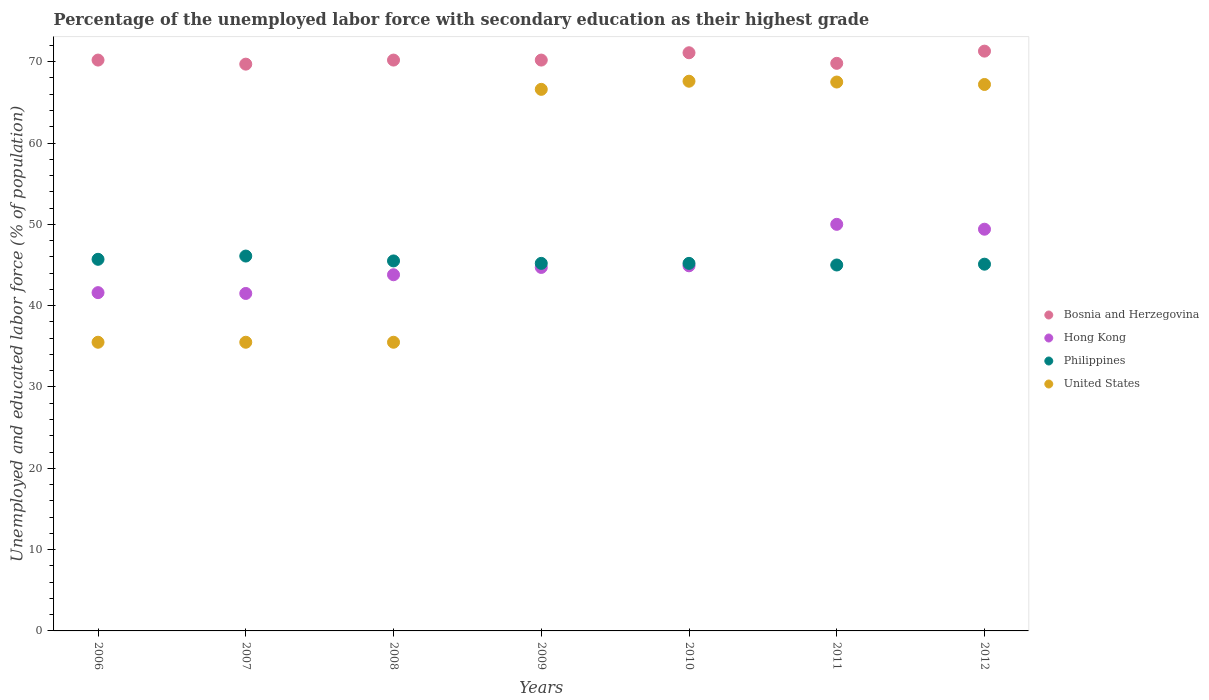What is the percentage of the unemployed labor force with secondary education in Philippines in 2010?
Keep it short and to the point. 45.2. Across all years, what is the maximum percentage of the unemployed labor force with secondary education in Philippines?
Keep it short and to the point. 46.1. Across all years, what is the minimum percentage of the unemployed labor force with secondary education in United States?
Give a very brief answer. 35.5. In which year was the percentage of the unemployed labor force with secondary education in United States maximum?
Provide a succinct answer. 2010. What is the total percentage of the unemployed labor force with secondary education in Philippines in the graph?
Provide a succinct answer. 317.8. What is the difference between the percentage of the unemployed labor force with secondary education in Philippines in 2006 and that in 2012?
Your response must be concise. 0.6. What is the average percentage of the unemployed labor force with secondary education in Hong Kong per year?
Keep it short and to the point. 45.13. In how many years, is the percentage of the unemployed labor force with secondary education in Hong Kong greater than 46 %?
Make the answer very short. 2. What is the ratio of the percentage of the unemployed labor force with secondary education in Hong Kong in 2007 to that in 2012?
Give a very brief answer. 0.84. What is the difference between the highest and the second highest percentage of the unemployed labor force with secondary education in Philippines?
Give a very brief answer. 0.4. What is the difference between the highest and the lowest percentage of the unemployed labor force with secondary education in Philippines?
Give a very brief answer. 1.1. In how many years, is the percentage of the unemployed labor force with secondary education in Bosnia and Herzegovina greater than the average percentage of the unemployed labor force with secondary education in Bosnia and Herzegovina taken over all years?
Offer a very short reply. 2. Is the sum of the percentage of the unemployed labor force with secondary education in United States in 2007 and 2012 greater than the maximum percentage of the unemployed labor force with secondary education in Hong Kong across all years?
Keep it short and to the point. Yes. Does the percentage of the unemployed labor force with secondary education in Bosnia and Herzegovina monotonically increase over the years?
Your answer should be very brief. No. Is the percentage of the unemployed labor force with secondary education in Bosnia and Herzegovina strictly less than the percentage of the unemployed labor force with secondary education in Philippines over the years?
Your answer should be very brief. No. How many dotlines are there?
Ensure brevity in your answer.  4. How many years are there in the graph?
Keep it short and to the point. 7. What is the difference between two consecutive major ticks on the Y-axis?
Offer a terse response. 10. Are the values on the major ticks of Y-axis written in scientific E-notation?
Provide a short and direct response. No. Does the graph contain any zero values?
Your answer should be compact. No. Does the graph contain grids?
Provide a short and direct response. No. Where does the legend appear in the graph?
Keep it short and to the point. Center right. What is the title of the graph?
Your answer should be compact. Percentage of the unemployed labor force with secondary education as their highest grade. What is the label or title of the Y-axis?
Your answer should be very brief. Unemployed and educated labor force (% of population). What is the Unemployed and educated labor force (% of population) of Bosnia and Herzegovina in 2006?
Give a very brief answer. 70.2. What is the Unemployed and educated labor force (% of population) in Hong Kong in 2006?
Give a very brief answer. 41.6. What is the Unemployed and educated labor force (% of population) in Philippines in 2006?
Offer a terse response. 45.7. What is the Unemployed and educated labor force (% of population) in United States in 2006?
Keep it short and to the point. 35.5. What is the Unemployed and educated labor force (% of population) of Bosnia and Herzegovina in 2007?
Ensure brevity in your answer.  69.7. What is the Unemployed and educated labor force (% of population) in Hong Kong in 2007?
Give a very brief answer. 41.5. What is the Unemployed and educated labor force (% of population) of Philippines in 2007?
Your response must be concise. 46.1. What is the Unemployed and educated labor force (% of population) of United States in 2007?
Offer a very short reply. 35.5. What is the Unemployed and educated labor force (% of population) of Bosnia and Herzegovina in 2008?
Keep it short and to the point. 70.2. What is the Unemployed and educated labor force (% of population) of Hong Kong in 2008?
Keep it short and to the point. 43.8. What is the Unemployed and educated labor force (% of population) of Philippines in 2008?
Your answer should be very brief. 45.5. What is the Unemployed and educated labor force (% of population) of United States in 2008?
Make the answer very short. 35.5. What is the Unemployed and educated labor force (% of population) of Bosnia and Herzegovina in 2009?
Offer a very short reply. 70.2. What is the Unemployed and educated labor force (% of population) of Hong Kong in 2009?
Provide a succinct answer. 44.7. What is the Unemployed and educated labor force (% of population) in Philippines in 2009?
Offer a very short reply. 45.2. What is the Unemployed and educated labor force (% of population) in United States in 2009?
Your answer should be very brief. 66.6. What is the Unemployed and educated labor force (% of population) in Bosnia and Herzegovina in 2010?
Offer a very short reply. 71.1. What is the Unemployed and educated labor force (% of population) in Hong Kong in 2010?
Offer a very short reply. 44.9. What is the Unemployed and educated labor force (% of population) in Philippines in 2010?
Your response must be concise. 45.2. What is the Unemployed and educated labor force (% of population) of United States in 2010?
Give a very brief answer. 67.6. What is the Unemployed and educated labor force (% of population) in Bosnia and Herzegovina in 2011?
Keep it short and to the point. 69.8. What is the Unemployed and educated labor force (% of population) of United States in 2011?
Provide a short and direct response. 67.5. What is the Unemployed and educated labor force (% of population) of Bosnia and Herzegovina in 2012?
Offer a terse response. 71.3. What is the Unemployed and educated labor force (% of population) in Hong Kong in 2012?
Ensure brevity in your answer.  49.4. What is the Unemployed and educated labor force (% of population) in Philippines in 2012?
Offer a terse response. 45.1. What is the Unemployed and educated labor force (% of population) of United States in 2012?
Your answer should be very brief. 67.2. Across all years, what is the maximum Unemployed and educated labor force (% of population) in Bosnia and Herzegovina?
Offer a very short reply. 71.3. Across all years, what is the maximum Unemployed and educated labor force (% of population) in Philippines?
Your answer should be compact. 46.1. Across all years, what is the maximum Unemployed and educated labor force (% of population) in United States?
Your answer should be very brief. 67.6. Across all years, what is the minimum Unemployed and educated labor force (% of population) in Bosnia and Herzegovina?
Ensure brevity in your answer.  69.7. Across all years, what is the minimum Unemployed and educated labor force (% of population) in Hong Kong?
Your answer should be very brief. 41.5. Across all years, what is the minimum Unemployed and educated labor force (% of population) of Philippines?
Your answer should be compact. 45. Across all years, what is the minimum Unemployed and educated labor force (% of population) in United States?
Make the answer very short. 35.5. What is the total Unemployed and educated labor force (% of population) of Bosnia and Herzegovina in the graph?
Provide a short and direct response. 492.5. What is the total Unemployed and educated labor force (% of population) in Hong Kong in the graph?
Ensure brevity in your answer.  315.9. What is the total Unemployed and educated labor force (% of population) in Philippines in the graph?
Ensure brevity in your answer.  317.8. What is the total Unemployed and educated labor force (% of population) of United States in the graph?
Offer a very short reply. 375.4. What is the difference between the Unemployed and educated labor force (% of population) of Philippines in 2006 and that in 2007?
Ensure brevity in your answer.  -0.4. What is the difference between the Unemployed and educated labor force (% of population) of Bosnia and Herzegovina in 2006 and that in 2008?
Give a very brief answer. 0. What is the difference between the Unemployed and educated labor force (% of population) of United States in 2006 and that in 2009?
Give a very brief answer. -31.1. What is the difference between the Unemployed and educated labor force (% of population) of Bosnia and Herzegovina in 2006 and that in 2010?
Make the answer very short. -0.9. What is the difference between the Unemployed and educated labor force (% of population) in Philippines in 2006 and that in 2010?
Your answer should be very brief. 0.5. What is the difference between the Unemployed and educated labor force (% of population) of United States in 2006 and that in 2010?
Provide a short and direct response. -32.1. What is the difference between the Unemployed and educated labor force (% of population) in Philippines in 2006 and that in 2011?
Offer a very short reply. 0.7. What is the difference between the Unemployed and educated labor force (% of population) in United States in 2006 and that in 2011?
Provide a short and direct response. -32. What is the difference between the Unemployed and educated labor force (% of population) in Hong Kong in 2006 and that in 2012?
Make the answer very short. -7.8. What is the difference between the Unemployed and educated labor force (% of population) in Philippines in 2006 and that in 2012?
Provide a succinct answer. 0.6. What is the difference between the Unemployed and educated labor force (% of population) in United States in 2006 and that in 2012?
Keep it short and to the point. -31.7. What is the difference between the Unemployed and educated labor force (% of population) of Philippines in 2007 and that in 2008?
Offer a very short reply. 0.6. What is the difference between the Unemployed and educated labor force (% of population) of United States in 2007 and that in 2008?
Provide a succinct answer. 0. What is the difference between the Unemployed and educated labor force (% of population) in Bosnia and Herzegovina in 2007 and that in 2009?
Provide a succinct answer. -0.5. What is the difference between the Unemployed and educated labor force (% of population) of Philippines in 2007 and that in 2009?
Your answer should be very brief. 0.9. What is the difference between the Unemployed and educated labor force (% of population) in United States in 2007 and that in 2009?
Ensure brevity in your answer.  -31.1. What is the difference between the Unemployed and educated labor force (% of population) of Bosnia and Herzegovina in 2007 and that in 2010?
Ensure brevity in your answer.  -1.4. What is the difference between the Unemployed and educated labor force (% of population) of United States in 2007 and that in 2010?
Offer a very short reply. -32.1. What is the difference between the Unemployed and educated labor force (% of population) in Bosnia and Herzegovina in 2007 and that in 2011?
Give a very brief answer. -0.1. What is the difference between the Unemployed and educated labor force (% of population) in Hong Kong in 2007 and that in 2011?
Provide a succinct answer. -8.5. What is the difference between the Unemployed and educated labor force (% of population) in United States in 2007 and that in 2011?
Ensure brevity in your answer.  -32. What is the difference between the Unemployed and educated labor force (% of population) of Hong Kong in 2007 and that in 2012?
Ensure brevity in your answer.  -7.9. What is the difference between the Unemployed and educated labor force (% of population) of United States in 2007 and that in 2012?
Make the answer very short. -31.7. What is the difference between the Unemployed and educated labor force (% of population) in United States in 2008 and that in 2009?
Give a very brief answer. -31.1. What is the difference between the Unemployed and educated labor force (% of population) in Bosnia and Herzegovina in 2008 and that in 2010?
Give a very brief answer. -0.9. What is the difference between the Unemployed and educated labor force (% of population) in Hong Kong in 2008 and that in 2010?
Offer a terse response. -1.1. What is the difference between the Unemployed and educated labor force (% of population) of United States in 2008 and that in 2010?
Keep it short and to the point. -32.1. What is the difference between the Unemployed and educated labor force (% of population) in Bosnia and Herzegovina in 2008 and that in 2011?
Offer a terse response. 0.4. What is the difference between the Unemployed and educated labor force (% of population) of Philippines in 2008 and that in 2011?
Offer a very short reply. 0.5. What is the difference between the Unemployed and educated labor force (% of population) in United States in 2008 and that in 2011?
Offer a terse response. -32. What is the difference between the Unemployed and educated labor force (% of population) of Philippines in 2008 and that in 2012?
Offer a very short reply. 0.4. What is the difference between the Unemployed and educated labor force (% of population) in United States in 2008 and that in 2012?
Make the answer very short. -31.7. What is the difference between the Unemployed and educated labor force (% of population) in Hong Kong in 2009 and that in 2010?
Your answer should be compact. -0.2. What is the difference between the Unemployed and educated labor force (% of population) in United States in 2009 and that in 2010?
Provide a short and direct response. -1. What is the difference between the Unemployed and educated labor force (% of population) of Hong Kong in 2009 and that in 2011?
Your answer should be very brief. -5.3. What is the difference between the Unemployed and educated labor force (% of population) of United States in 2009 and that in 2011?
Your answer should be compact. -0.9. What is the difference between the Unemployed and educated labor force (% of population) in Hong Kong in 2009 and that in 2012?
Provide a succinct answer. -4.7. What is the difference between the Unemployed and educated labor force (% of population) in United States in 2009 and that in 2012?
Give a very brief answer. -0.6. What is the difference between the Unemployed and educated labor force (% of population) of Bosnia and Herzegovina in 2010 and that in 2011?
Keep it short and to the point. 1.3. What is the difference between the Unemployed and educated labor force (% of population) of Philippines in 2010 and that in 2011?
Provide a succinct answer. 0.2. What is the difference between the Unemployed and educated labor force (% of population) in Bosnia and Herzegovina in 2010 and that in 2012?
Make the answer very short. -0.2. What is the difference between the Unemployed and educated labor force (% of population) in Hong Kong in 2010 and that in 2012?
Your response must be concise. -4.5. What is the difference between the Unemployed and educated labor force (% of population) of Bosnia and Herzegovina in 2011 and that in 2012?
Provide a short and direct response. -1.5. What is the difference between the Unemployed and educated labor force (% of population) of Hong Kong in 2011 and that in 2012?
Make the answer very short. 0.6. What is the difference between the Unemployed and educated labor force (% of population) of Philippines in 2011 and that in 2012?
Provide a short and direct response. -0.1. What is the difference between the Unemployed and educated labor force (% of population) of Bosnia and Herzegovina in 2006 and the Unemployed and educated labor force (% of population) of Hong Kong in 2007?
Your answer should be very brief. 28.7. What is the difference between the Unemployed and educated labor force (% of population) of Bosnia and Herzegovina in 2006 and the Unemployed and educated labor force (% of population) of Philippines in 2007?
Give a very brief answer. 24.1. What is the difference between the Unemployed and educated labor force (% of population) of Bosnia and Herzegovina in 2006 and the Unemployed and educated labor force (% of population) of United States in 2007?
Provide a succinct answer. 34.7. What is the difference between the Unemployed and educated labor force (% of population) of Hong Kong in 2006 and the Unemployed and educated labor force (% of population) of United States in 2007?
Keep it short and to the point. 6.1. What is the difference between the Unemployed and educated labor force (% of population) in Philippines in 2006 and the Unemployed and educated labor force (% of population) in United States in 2007?
Provide a short and direct response. 10.2. What is the difference between the Unemployed and educated labor force (% of population) of Bosnia and Herzegovina in 2006 and the Unemployed and educated labor force (% of population) of Hong Kong in 2008?
Ensure brevity in your answer.  26.4. What is the difference between the Unemployed and educated labor force (% of population) of Bosnia and Herzegovina in 2006 and the Unemployed and educated labor force (% of population) of Philippines in 2008?
Provide a short and direct response. 24.7. What is the difference between the Unemployed and educated labor force (% of population) in Bosnia and Herzegovina in 2006 and the Unemployed and educated labor force (% of population) in United States in 2008?
Provide a short and direct response. 34.7. What is the difference between the Unemployed and educated labor force (% of population) of Philippines in 2006 and the Unemployed and educated labor force (% of population) of United States in 2008?
Provide a succinct answer. 10.2. What is the difference between the Unemployed and educated labor force (% of population) in Bosnia and Herzegovina in 2006 and the Unemployed and educated labor force (% of population) in Hong Kong in 2009?
Your answer should be compact. 25.5. What is the difference between the Unemployed and educated labor force (% of population) in Hong Kong in 2006 and the Unemployed and educated labor force (% of population) in Philippines in 2009?
Provide a short and direct response. -3.6. What is the difference between the Unemployed and educated labor force (% of population) of Philippines in 2006 and the Unemployed and educated labor force (% of population) of United States in 2009?
Offer a very short reply. -20.9. What is the difference between the Unemployed and educated labor force (% of population) of Bosnia and Herzegovina in 2006 and the Unemployed and educated labor force (% of population) of Hong Kong in 2010?
Your answer should be compact. 25.3. What is the difference between the Unemployed and educated labor force (% of population) of Bosnia and Herzegovina in 2006 and the Unemployed and educated labor force (% of population) of United States in 2010?
Keep it short and to the point. 2.6. What is the difference between the Unemployed and educated labor force (% of population) of Hong Kong in 2006 and the Unemployed and educated labor force (% of population) of United States in 2010?
Your answer should be compact. -26. What is the difference between the Unemployed and educated labor force (% of population) in Philippines in 2006 and the Unemployed and educated labor force (% of population) in United States in 2010?
Your response must be concise. -21.9. What is the difference between the Unemployed and educated labor force (% of population) of Bosnia and Herzegovina in 2006 and the Unemployed and educated labor force (% of population) of Hong Kong in 2011?
Your answer should be compact. 20.2. What is the difference between the Unemployed and educated labor force (% of population) in Bosnia and Herzegovina in 2006 and the Unemployed and educated labor force (% of population) in Philippines in 2011?
Offer a very short reply. 25.2. What is the difference between the Unemployed and educated labor force (% of population) in Hong Kong in 2006 and the Unemployed and educated labor force (% of population) in Philippines in 2011?
Offer a terse response. -3.4. What is the difference between the Unemployed and educated labor force (% of population) in Hong Kong in 2006 and the Unemployed and educated labor force (% of population) in United States in 2011?
Give a very brief answer. -25.9. What is the difference between the Unemployed and educated labor force (% of population) in Philippines in 2006 and the Unemployed and educated labor force (% of population) in United States in 2011?
Give a very brief answer. -21.8. What is the difference between the Unemployed and educated labor force (% of population) in Bosnia and Herzegovina in 2006 and the Unemployed and educated labor force (% of population) in Hong Kong in 2012?
Give a very brief answer. 20.8. What is the difference between the Unemployed and educated labor force (% of population) of Bosnia and Herzegovina in 2006 and the Unemployed and educated labor force (% of population) of Philippines in 2012?
Your response must be concise. 25.1. What is the difference between the Unemployed and educated labor force (% of population) in Hong Kong in 2006 and the Unemployed and educated labor force (% of population) in Philippines in 2012?
Keep it short and to the point. -3.5. What is the difference between the Unemployed and educated labor force (% of population) in Hong Kong in 2006 and the Unemployed and educated labor force (% of population) in United States in 2012?
Your response must be concise. -25.6. What is the difference between the Unemployed and educated labor force (% of population) of Philippines in 2006 and the Unemployed and educated labor force (% of population) of United States in 2012?
Offer a very short reply. -21.5. What is the difference between the Unemployed and educated labor force (% of population) in Bosnia and Herzegovina in 2007 and the Unemployed and educated labor force (% of population) in Hong Kong in 2008?
Keep it short and to the point. 25.9. What is the difference between the Unemployed and educated labor force (% of population) in Bosnia and Herzegovina in 2007 and the Unemployed and educated labor force (% of population) in Philippines in 2008?
Keep it short and to the point. 24.2. What is the difference between the Unemployed and educated labor force (% of population) of Bosnia and Herzegovina in 2007 and the Unemployed and educated labor force (% of population) of United States in 2008?
Your answer should be very brief. 34.2. What is the difference between the Unemployed and educated labor force (% of population) of Hong Kong in 2007 and the Unemployed and educated labor force (% of population) of United States in 2008?
Offer a terse response. 6. What is the difference between the Unemployed and educated labor force (% of population) in Bosnia and Herzegovina in 2007 and the Unemployed and educated labor force (% of population) in Hong Kong in 2009?
Provide a short and direct response. 25. What is the difference between the Unemployed and educated labor force (% of population) of Hong Kong in 2007 and the Unemployed and educated labor force (% of population) of Philippines in 2009?
Give a very brief answer. -3.7. What is the difference between the Unemployed and educated labor force (% of population) in Hong Kong in 2007 and the Unemployed and educated labor force (% of population) in United States in 2009?
Give a very brief answer. -25.1. What is the difference between the Unemployed and educated labor force (% of population) in Philippines in 2007 and the Unemployed and educated labor force (% of population) in United States in 2009?
Your response must be concise. -20.5. What is the difference between the Unemployed and educated labor force (% of population) in Bosnia and Herzegovina in 2007 and the Unemployed and educated labor force (% of population) in Hong Kong in 2010?
Make the answer very short. 24.8. What is the difference between the Unemployed and educated labor force (% of population) of Bosnia and Herzegovina in 2007 and the Unemployed and educated labor force (% of population) of Philippines in 2010?
Ensure brevity in your answer.  24.5. What is the difference between the Unemployed and educated labor force (% of population) in Bosnia and Herzegovina in 2007 and the Unemployed and educated labor force (% of population) in United States in 2010?
Offer a very short reply. 2.1. What is the difference between the Unemployed and educated labor force (% of population) of Hong Kong in 2007 and the Unemployed and educated labor force (% of population) of Philippines in 2010?
Offer a very short reply. -3.7. What is the difference between the Unemployed and educated labor force (% of population) of Hong Kong in 2007 and the Unemployed and educated labor force (% of population) of United States in 2010?
Make the answer very short. -26.1. What is the difference between the Unemployed and educated labor force (% of population) of Philippines in 2007 and the Unemployed and educated labor force (% of population) of United States in 2010?
Provide a succinct answer. -21.5. What is the difference between the Unemployed and educated labor force (% of population) in Bosnia and Herzegovina in 2007 and the Unemployed and educated labor force (% of population) in Philippines in 2011?
Provide a succinct answer. 24.7. What is the difference between the Unemployed and educated labor force (% of population) in Bosnia and Herzegovina in 2007 and the Unemployed and educated labor force (% of population) in United States in 2011?
Provide a short and direct response. 2.2. What is the difference between the Unemployed and educated labor force (% of population) of Philippines in 2007 and the Unemployed and educated labor force (% of population) of United States in 2011?
Keep it short and to the point. -21.4. What is the difference between the Unemployed and educated labor force (% of population) in Bosnia and Herzegovina in 2007 and the Unemployed and educated labor force (% of population) in Hong Kong in 2012?
Ensure brevity in your answer.  20.3. What is the difference between the Unemployed and educated labor force (% of population) of Bosnia and Herzegovina in 2007 and the Unemployed and educated labor force (% of population) of Philippines in 2012?
Provide a succinct answer. 24.6. What is the difference between the Unemployed and educated labor force (% of population) in Bosnia and Herzegovina in 2007 and the Unemployed and educated labor force (% of population) in United States in 2012?
Ensure brevity in your answer.  2.5. What is the difference between the Unemployed and educated labor force (% of population) of Hong Kong in 2007 and the Unemployed and educated labor force (% of population) of Philippines in 2012?
Provide a short and direct response. -3.6. What is the difference between the Unemployed and educated labor force (% of population) of Hong Kong in 2007 and the Unemployed and educated labor force (% of population) of United States in 2012?
Keep it short and to the point. -25.7. What is the difference between the Unemployed and educated labor force (% of population) of Philippines in 2007 and the Unemployed and educated labor force (% of population) of United States in 2012?
Keep it short and to the point. -21.1. What is the difference between the Unemployed and educated labor force (% of population) in Hong Kong in 2008 and the Unemployed and educated labor force (% of population) in Philippines in 2009?
Your answer should be very brief. -1.4. What is the difference between the Unemployed and educated labor force (% of population) of Hong Kong in 2008 and the Unemployed and educated labor force (% of population) of United States in 2009?
Offer a very short reply. -22.8. What is the difference between the Unemployed and educated labor force (% of population) of Philippines in 2008 and the Unemployed and educated labor force (% of population) of United States in 2009?
Ensure brevity in your answer.  -21.1. What is the difference between the Unemployed and educated labor force (% of population) of Bosnia and Herzegovina in 2008 and the Unemployed and educated labor force (% of population) of Hong Kong in 2010?
Offer a very short reply. 25.3. What is the difference between the Unemployed and educated labor force (% of population) of Bosnia and Herzegovina in 2008 and the Unemployed and educated labor force (% of population) of Philippines in 2010?
Your answer should be very brief. 25. What is the difference between the Unemployed and educated labor force (% of population) in Hong Kong in 2008 and the Unemployed and educated labor force (% of population) in Philippines in 2010?
Provide a succinct answer. -1.4. What is the difference between the Unemployed and educated labor force (% of population) of Hong Kong in 2008 and the Unemployed and educated labor force (% of population) of United States in 2010?
Offer a terse response. -23.8. What is the difference between the Unemployed and educated labor force (% of population) in Philippines in 2008 and the Unemployed and educated labor force (% of population) in United States in 2010?
Ensure brevity in your answer.  -22.1. What is the difference between the Unemployed and educated labor force (% of population) of Bosnia and Herzegovina in 2008 and the Unemployed and educated labor force (% of population) of Hong Kong in 2011?
Your answer should be compact. 20.2. What is the difference between the Unemployed and educated labor force (% of population) in Bosnia and Herzegovina in 2008 and the Unemployed and educated labor force (% of population) in Philippines in 2011?
Give a very brief answer. 25.2. What is the difference between the Unemployed and educated labor force (% of population) in Bosnia and Herzegovina in 2008 and the Unemployed and educated labor force (% of population) in United States in 2011?
Keep it short and to the point. 2.7. What is the difference between the Unemployed and educated labor force (% of population) of Hong Kong in 2008 and the Unemployed and educated labor force (% of population) of United States in 2011?
Keep it short and to the point. -23.7. What is the difference between the Unemployed and educated labor force (% of population) in Philippines in 2008 and the Unemployed and educated labor force (% of population) in United States in 2011?
Provide a succinct answer. -22. What is the difference between the Unemployed and educated labor force (% of population) of Bosnia and Herzegovina in 2008 and the Unemployed and educated labor force (% of population) of Hong Kong in 2012?
Your answer should be very brief. 20.8. What is the difference between the Unemployed and educated labor force (% of population) of Bosnia and Herzegovina in 2008 and the Unemployed and educated labor force (% of population) of Philippines in 2012?
Provide a succinct answer. 25.1. What is the difference between the Unemployed and educated labor force (% of population) in Bosnia and Herzegovina in 2008 and the Unemployed and educated labor force (% of population) in United States in 2012?
Keep it short and to the point. 3. What is the difference between the Unemployed and educated labor force (% of population) in Hong Kong in 2008 and the Unemployed and educated labor force (% of population) in Philippines in 2012?
Give a very brief answer. -1.3. What is the difference between the Unemployed and educated labor force (% of population) in Hong Kong in 2008 and the Unemployed and educated labor force (% of population) in United States in 2012?
Make the answer very short. -23.4. What is the difference between the Unemployed and educated labor force (% of population) of Philippines in 2008 and the Unemployed and educated labor force (% of population) of United States in 2012?
Give a very brief answer. -21.7. What is the difference between the Unemployed and educated labor force (% of population) of Bosnia and Herzegovina in 2009 and the Unemployed and educated labor force (% of population) of Hong Kong in 2010?
Make the answer very short. 25.3. What is the difference between the Unemployed and educated labor force (% of population) in Bosnia and Herzegovina in 2009 and the Unemployed and educated labor force (% of population) in United States in 2010?
Make the answer very short. 2.6. What is the difference between the Unemployed and educated labor force (% of population) in Hong Kong in 2009 and the Unemployed and educated labor force (% of population) in Philippines in 2010?
Provide a succinct answer. -0.5. What is the difference between the Unemployed and educated labor force (% of population) in Hong Kong in 2009 and the Unemployed and educated labor force (% of population) in United States in 2010?
Give a very brief answer. -22.9. What is the difference between the Unemployed and educated labor force (% of population) of Philippines in 2009 and the Unemployed and educated labor force (% of population) of United States in 2010?
Offer a terse response. -22.4. What is the difference between the Unemployed and educated labor force (% of population) in Bosnia and Herzegovina in 2009 and the Unemployed and educated labor force (% of population) in Hong Kong in 2011?
Your answer should be very brief. 20.2. What is the difference between the Unemployed and educated labor force (% of population) of Bosnia and Herzegovina in 2009 and the Unemployed and educated labor force (% of population) of Philippines in 2011?
Give a very brief answer. 25.2. What is the difference between the Unemployed and educated labor force (% of population) of Bosnia and Herzegovina in 2009 and the Unemployed and educated labor force (% of population) of United States in 2011?
Your answer should be compact. 2.7. What is the difference between the Unemployed and educated labor force (% of population) in Hong Kong in 2009 and the Unemployed and educated labor force (% of population) in United States in 2011?
Ensure brevity in your answer.  -22.8. What is the difference between the Unemployed and educated labor force (% of population) in Philippines in 2009 and the Unemployed and educated labor force (% of population) in United States in 2011?
Provide a short and direct response. -22.3. What is the difference between the Unemployed and educated labor force (% of population) in Bosnia and Herzegovina in 2009 and the Unemployed and educated labor force (% of population) in Hong Kong in 2012?
Your answer should be very brief. 20.8. What is the difference between the Unemployed and educated labor force (% of population) in Bosnia and Herzegovina in 2009 and the Unemployed and educated labor force (% of population) in Philippines in 2012?
Provide a short and direct response. 25.1. What is the difference between the Unemployed and educated labor force (% of population) of Hong Kong in 2009 and the Unemployed and educated labor force (% of population) of United States in 2012?
Provide a short and direct response. -22.5. What is the difference between the Unemployed and educated labor force (% of population) of Philippines in 2009 and the Unemployed and educated labor force (% of population) of United States in 2012?
Your response must be concise. -22. What is the difference between the Unemployed and educated labor force (% of population) in Bosnia and Herzegovina in 2010 and the Unemployed and educated labor force (% of population) in Hong Kong in 2011?
Offer a terse response. 21.1. What is the difference between the Unemployed and educated labor force (% of population) in Bosnia and Herzegovina in 2010 and the Unemployed and educated labor force (% of population) in Philippines in 2011?
Provide a succinct answer. 26.1. What is the difference between the Unemployed and educated labor force (% of population) of Hong Kong in 2010 and the Unemployed and educated labor force (% of population) of United States in 2011?
Provide a short and direct response. -22.6. What is the difference between the Unemployed and educated labor force (% of population) in Philippines in 2010 and the Unemployed and educated labor force (% of population) in United States in 2011?
Your response must be concise. -22.3. What is the difference between the Unemployed and educated labor force (% of population) of Bosnia and Herzegovina in 2010 and the Unemployed and educated labor force (% of population) of Hong Kong in 2012?
Ensure brevity in your answer.  21.7. What is the difference between the Unemployed and educated labor force (% of population) in Bosnia and Herzegovina in 2010 and the Unemployed and educated labor force (% of population) in United States in 2012?
Keep it short and to the point. 3.9. What is the difference between the Unemployed and educated labor force (% of population) in Hong Kong in 2010 and the Unemployed and educated labor force (% of population) in Philippines in 2012?
Provide a short and direct response. -0.2. What is the difference between the Unemployed and educated labor force (% of population) of Hong Kong in 2010 and the Unemployed and educated labor force (% of population) of United States in 2012?
Provide a short and direct response. -22.3. What is the difference between the Unemployed and educated labor force (% of population) in Philippines in 2010 and the Unemployed and educated labor force (% of population) in United States in 2012?
Your answer should be very brief. -22. What is the difference between the Unemployed and educated labor force (% of population) of Bosnia and Herzegovina in 2011 and the Unemployed and educated labor force (% of population) of Hong Kong in 2012?
Offer a terse response. 20.4. What is the difference between the Unemployed and educated labor force (% of population) in Bosnia and Herzegovina in 2011 and the Unemployed and educated labor force (% of population) in Philippines in 2012?
Make the answer very short. 24.7. What is the difference between the Unemployed and educated labor force (% of population) of Bosnia and Herzegovina in 2011 and the Unemployed and educated labor force (% of population) of United States in 2012?
Your answer should be compact. 2.6. What is the difference between the Unemployed and educated labor force (% of population) in Hong Kong in 2011 and the Unemployed and educated labor force (% of population) in United States in 2012?
Offer a terse response. -17.2. What is the difference between the Unemployed and educated labor force (% of population) in Philippines in 2011 and the Unemployed and educated labor force (% of population) in United States in 2012?
Give a very brief answer. -22.2. What is the average Unemployed and educated labor force (% of population) in Bosnia and Herzegovina per year?
Your answer should be compact. 70.36. What is the average Unemployed and educated labor force (% of population) in Hong Kong per year?
Offer a terse response. 45.13. What is the average Unemployed and educated labor force (% of population) of Philippines per year?
Offer a terse response. 45.4. What is the average Unemployed and educated labor force (% of population) of United States per year?
Make the answer very short. 53.63. In the year 2006, what is the difference between the Unemployed and educated labor force (% of population) of Bosnia and Herzegovina and Unemployed and educated labor force (% of population) of Hong Kong?
Provide a short and direct response. 28.6. In the year 2006, what is the difference between the Unemployed and educated labor force (% of population) of Bosnia and Herzegovina and Unemployed and educated labor force (% of population) of Philippines?
Your response must be concise. 24.5. In the year 2006, what is the difference between the Unemployed and educated labor force (% of population) of Bosnia and Herzegovina and Unemployed and educated labor force (% of population) of United States?
Your answer should be very brief. 34.7. In the year 2006, what is the difference between the Unemployed and educated labor force (% of population) in Hong Kong and Unemployed and educated labor force (% of population) in United States?
Keep it short and to the point. 6.1. In the year 2007, what is the difference between the Unemployed and educated labor force (% of population) in Bosnia and Herzegovina and Unemployed and educated labor force (% of population) in Hong Kong?
Give a very brief answer. 28.2. In the year 2007, what is the difference between the Unemployed and educated labor force (% of population) of Bosnia and Herzegovina and Unemployed and educated labor force (% of population) of Philippines?
Keep it short and to the point. 23.6. In the year 2007, what is the difference between the Unemployed and educated labor force (% of population) in Bosnia and Herzegovina and Unemployed and educated labor force (% of population) in United States?
Offer a terse response. 34.2. In the year 2007, what is the difference between the Unemployed and educated labor force (% of population) of Hong Kong and Unemployed and educated labor force (% of population) of Philippines?
Offer a terse response. -4.6. In the year 2007, what is the difference between the Unemployed and educated labor force (% of population) of Hong Kong and Unemployed and educated labor force (% of population) of United States?
Make the answer very short. 6. In the year 2008, what is the difference between the Unemployed and educated labor force (% of population) of Bosnia and Herzegovina and Unemployed and educated labor force (% of population) of Hong Kong?
Make the answer very short. 26.4. In the year 2008, what is the difference between the Unemployed and educated labor force (% of population) of Bosnia and Herzegovina and Unemployed and educated labor force (% of population) of Philippines?
Provide a succinct answer. 24.7. In the year 2008, what is the difference between the Unemployed and educated labor force (% of population) in Bosnia and Herzegovina and Unemployed and educated labor force (% of population) in United States?
Your answer should be very brief. 34.7. In the year 2008, what is the difference between the Unemployed and educated labor force (% of population) in Hong Kong and Unemployed and educated labor force (% of population) in Philippines?
Provide a short and direct response. -1.7. In the year 2009, what is the difference between the Unemployed and educated labor force (% of population) in Bosnia and Herzegovina and Unemployed and educated labor force (% of population) in Philippines?
Your response must be concise. 25. In the year 2009, what is the difference between the Unemployed and educated labor force (% of population) of Hong Kong and Unemployed and educated labor force (% of population) of United States?
Make the answer very short. -21.9. In the year 2009, what is the difference between the Unemployed and educated labor force (% of population) of Philippines and Unemployed and educated labor force (% of population) of United States?
Provide a short and direct response. -21.4. In the year 2010, what is the difference between the Unemployed and educated labor force (% of population) of Bosnia and Herzegovina and Unemployed and educated labor force (% of population) of Hong Kong?
Provide a succinct answer. 26.2. In the year 2010, what is the difference between the Unemployed and educated labor force (% of population) of Bosnia and Herzegovina and Unemployed and educated labor force (% of population) of Philippines?
Provide a short and direct response. 25.9. In the year 2010, what is the difference between the Unemployed and educated labor force (% of population) of Hong Kong and Unemployed and educated labor force (% of population) of Philippines?
Your response must be concise. -0.3. In the year 2010, what is the difference between the Unemployed and educated labor force (% of population) in Hong Kong and Unemployed and educated labor force (% of population) in United States?
Keep it short and to the point. -22.7. In the year 2010, what is the difference between the Unemployed and educated labor force (% of population) in Philippines and Unemployed and educated labor force (% of population) in United States?
Offer a terse response. -22.4. In the year 2011, what is the difference between the Unemployed and educated labor force (% of population) of Bosnia and Herzegovina and Unemployed and educated labor force (% of population) of Hong Kong?
Provide a succinct answer. 19.8. In the year 2011, what is the difference between the Unemployed and educated labor force (% of population) of Bosnia and Herzegovina and Unemployed and educated labor force (% of population) of Philippines?
Provide a succinct answer. 24.8. In the year 2011, what is the difference between the Unemployed and educated labor force (% of population) of Bosnia and Herzegovina and Unemployed and educated labor force (% of population) of United States?
Your answer should be very brief. 2.3. In the year 2011, what is the difference between the Unemployed and educated labor force (% of population) in Hong Kong and Unemployed and educated labor force (% of population) in Philippines?
Make the answer very short. 5. In the year 2011, what is the difference between the Unemployed and educated labor force (% of population) in Hong Kong and Unemployed and educated labor force (% of population) in United States?
Make the answer very short. -17.5. In the year 2011, what is the difference between the Unemployed and educated labor force (% of population) in Philippines and Unemployed and educated labor force (% of population) in United States?
Provide a short and direct response. -22.5. In the year 2012, what is the difference between the Unemployed and educated labor force (% of population) of Bosnia and Herzegovina and Unemployed and educated labor force (% of population) of Hong Kong?
Ensure brevity in your answer.  21.9. In the year 2012, what is the difference between the Unemployed and educated labor force (% of population) in Bosnia and Herzegovina and Unemployed and educated labor force (% of population) in Philippines?
Offer a terse response. 26.2. In the year 2012, what is the difference between the Unemployed and educated labor force (% of population) in Bosnia and Herzegovina and Unemployed and educated labor force (% of population) in United States?
Your answer should be compact. 4.1. In the year 2012, what is the difference between the Unemployed and educated labor force (% of population) in Hong Kong and Unemployed and educated labor force (% of population) in Philippines?
Give a very brief answer. 4.3. In the year 2012, what is the difference between the Unemployed and educated labor force (% of population) of Hong Kong and Unemployed and educated labor force (% of population) of United States?
Your response must be concise. -17.8. In the year 2012, what is the difference between the Unemployed and educated labor force (% of population) of Philippines and Unemployed and educated labor force (% of population) of United States?
Give a very brief answer. -22.1. What is the ratio of the Unemployed and educated labor force (% of population) of Hong Kong in 2006 to that in 2007?
Ensure brevity in your answer.  1. What is the ratio of the Unemployed and educated labor force (% of population) of Bosnia and Herzegovina in 2006 to that in 2008?
Provide a short and direct response. 1. What is the ratio of the Unemployed and educated labor force (% of population) in Hong Kong in 2006 to that in 2008?
Your answer should be compact. 0.95. What is the ratio of the Unemployed and educated labor force (% of population) in Bosnia and Herzegovina in 2006 to that in 2009?
Provide a succinct answer. 1. What is the ratio of the Unemployed and educated labor force (% of population) of Hong Kong in 2006 to that in 2009?
Provide a succinct answer. 0.93. What is the ratio of the Unemployed and educated labor force (% of population) of Philippines in 2006 to that in 2009?
Provide a succinct answer. 1.01. What is the ratio of the Unemployed and educated labor force (% of population) in United States in 2006 to that in 2009?
Keep it short and to the point. 0.53. What is the ratio of the Unemployed and educated labor force (% of population) of Bosnia and Herzegovina in 2006 to that in 2010?
Offer a terse response. 0.99. What is the ratio of the Unemployed and educated labor force (% of population) of Hong Kong in 2006 to that in 2010?
Provide a short and direct response. 0.93. What is the ratio of the Unemployed and educated labor force (% of population) of Philippines in 2006 to that in 2010?
Offer a terse response. 1.01. What is the ratio of the Unemployed and educated labor force (% of population) in United States in 2006 to that in 2010?
Ensure brevity in your answer.  0.53. What is the ratio of the Unemployed and educated labor force (% of population) in Bosnia and Herzegovina in 2006 to that in 2011?
Provide a succinct answer. 1.01. What is the ratio of the Unemployed and educated labor force (% of population) in Hong Kong in 2006 to that in 2011?
Ensure brevity in your answer.  0.83. What is the ratio of the Unemployed and educated labor force (% of population) in Philippines in 2006 to that in 2011?
Provide a succinct answer. 1.02. What is the ratio of the Unemployed and educated labor force (% of population) of United States in 2006 to that in 2011?
Give a very brief answer. 0.53. What is the ratio of the Unemployed and educated labor force (% of population) of Bosnia and Herzegovina in 2006 to that in 2012?
Provide a short and direct response. 0.98. What is the ratio of the Unemployed and educated labor force (% of population) of Hong Kong in 2006 to that in 2012?
Give a very brief answer. 0.84. What is the ratio of the Unemployed and educated labor force (% of population) of Philippines in 2006 to that in 2012?
Keep it short and to the point. 1.01. What is the ratio of the Unemployed and educated labor force (% of population) of United States in 2006 to that in 2012?
Offer a terse response. 0.53. What is the ratio of the Unemployed and educated labor force (% of population) in Bosnia and Herzegovina in 2007 to that in 2008?
Offer a very short reply. 0.99. What is the ratio of the Unemployed and educated labor force (% of population) in Hong Kong in 2007 to that in 2008?
Offer a terse response. 0.95. What is the ratio of the Unemployed and educated labor force (% of population) of Philippines in 2007 to that in 2008?
Provide a short and direct response. 1.01. What is the ratio of the Unemployed and educated labor force (% of population) of United States in 2007 to that in 2008?
Make the answer very short. 1. What is the ratio of the Unemployed and educated labor force (% of population) of Hong Kong in 2007 to that in 2009?
Your answer should be compact. 0.93. What is the ratio of the Unemployed and educated labor force (% of population) in Philippines in 2007 to that in 2009?
Give a very brief answer. 1.02. What is the ratio of the Unemployed and educated labor force (% of population) in United States in 2007 to that in 2009?
Provide a short and direct response. 0.53. What is the ratio of the Unemployed and educated labor force (% of population) of Bosnia and Herzegovina in 2007 to that in 2010?
Your answer should be very brief. 0.98. What is the ratio of the Unemployed and educated labor force (% of population) in Hong Kong in 2007 to that in 2010?
Offer a very short reply. 0.92. What is the ratio of the Unemployed and educated labor force (% of population) in Philippines in 2007 to that in 2010?
Ensure brevity in your answer.  1.02. What is the ratio of the Unemployed and educated labor force (% of population) in United States in 2007 to that in 2010?
Provide a short and direct response. 0.53. What is the ratio of the Unemployed and educated labor force (% of population) of Bosnia and Herzegovina in 2007 to that in 2011?
Offer a terse response. 1. What is the ratio of the Unemployed and educated labor force (% of population) of Hong Kong in 2007 to that in 2011?
Offer a terse response. 0.83. What is the ratio of the Unemployed and educated labor force (% of population) in Philippines in 2007 to that in 2011?
Make the answer very short. 1.02. What is the ratio of the Unemployed and educated labor force (% of population) of United States in 2007 to that in 2011?
Your answer should be very brief. 0.53. What is the ratio of the Unemployed and educated labor force (% of population) in Bosnia and Herzegovina in 2007 to that in 2012?
Your response must be concise. 0.98. What is the ratio of the Unemployed and educated labor force (% of population) of Hong Kong in 2007 to that in 2012?
Offer a very short reply. 0.84. What is the ratio of the Unemployed and educated labor force (% of population) in Philippines in 2007 to that in 2012?
Your answer should be compact. 1.02. What is the ratio of the Unemployed and educated labor force (% of population) of United States in 2007 to that in 2012?
Provide a succinct answer. 0.53. What is the ratio of the Unemployed and educated labor force (% of population) in Hong Kong in 2008 to that in 2009?
Provide a short and direct response. 0.98. What is the ratio of the Unemployed and educated labor force (% of population) of Philippines in 2008 to that in 2009?
Your answer should be compact. 1.01. What is the ratio of the Unemployed and educated labor force (% of population) in United States in 2008 to that in 2009?
Keep it short and to the point. 0.53. What is the ratio of the Unemployed and educated labor force (% of population) in Bosnia and Herzegovina in 2008 to that in 2010?
Make the answer very short. 0.99. What is the ratio of the Unemployed and educated labor force (% of population) of Hong Kong in 2008 to that in 2010?
Offer a terse response. 0.98. What is the ratio of the Unemployed and educated labor force (% of population) of Philippines in 2008 to that in 2010?
Make the answer very short. 1.01. What is the ratio of the Unemployed and educated labor force (% of population) of United States in 2008 to that in 2010?
Offer a very short reply. 0.53. What is the ratio of the Unemployed and educated labor force (% of population) of Bosnia and Herzegovina in 2008 to that in 2011?
Offer a terse response. 1.01. What is the ratio of the Unemployed and educated labor force (% of population) in Hong Kong in 2008 to that in 2011?
Your answer should be very brief. 0.88. What is the ratio of the Unemployed and educated labor force (% of population) in Philippines in 2008 to that in 2011?
Keep it short and to the point. 1.01. What is the ratio of the Unemployed and educated labor force (% of population) of United States in 2008 to that in 2011?
Offer a terse response. 0.53. What is the ratio of the Unemployed and educated labor force (% of population) in Bosnia and Herzegovina in 2008 to that in 2012?
Offer a very short reply. 0.98. What is the ratio of the Unemployed and educated labor force (% of population) of Hong Kong in 2008 to that in 2012?
Provide a short and direct response. 0.89. What is the ratio of the Unemployed and educated labor force (% of population) in Philippines in 2008 to that in 2012?
Offer a very short reply. 1.01. What is the ratio of the Unemployed and educated labor force (% of population) in United States in 2008 to that in 2012?
Offer a very short reply. 0.53. What is the ratio of the Unemployed and educated labor force (% of population) of Bosnia and Herzegovina in 2009 to that in 2010?
Ensure brevity in your answer.  0.99. What is the ratio of the Unemployed and educated labor force (% of population) of Hong Kong in 2009 to that in 2010?
Your answer should be very brief. 1. What is the ratio of the Unemployed and educated labor force (% of population) of Philippines in 2009 to that in 2010?
Make the answer very short. 1. What is the ratio of the Unemployed and educated labor force (% of population) in United States in 2009 to that in 2010?
Offer a very short reply. 0.99. What is the ratio of the Unemployed and educated labor force (% of population) in Bosnia and Herzegovina in 2009 to that in 2011?
Provide a short and direct response. 1.01. What is the ratio of the Unemployed and educated labor force (% of population) of Hong Kong in 2009 to that in 2011?
Keep it short and to the point. 0.89. What is the ratio of the Unemployed and educated labor force (% of population) of Philippines in 2009 to that in 2011?
Give a very brief answer. 1. What is the ratio of the Unemployed and educated labor force (% of population) of United States in 2009 to that in 2011?
Your answer should be very brief. 0.99. What is the ratio of the Unemployed and educated labor force (% of population) in Bosnia and Herzegovina in 2009 to that in 2012?
Your response must be concise. 0.98. What is the ratio of the Unemployed and educated labor force (% of population) in Hong Kong in 2009 to that in 2012?
Keep it short and to the point. 0.9. What is the ratio of the Unemployed and educated labor force (% of population) in Bosnia and Herzegovina in 2010 to that in 2011?
Provide a succinct answer. 1.02. What is the ratio of the Unemployed and educated labor force (% of population) in Hong Kong in 2010 to that in 2011?
Your answer should be compact. 0.9. What is the ratio of the Unemployed and educated labor force (% of population) in Philippines in 2010 to that in 2011?
Give a very brief answer. 1. What is the ratio of the Unemployed and educated labor force (% of population) in Hong Kong in 2010 to that in 2012?
Your answer should be very brief. 0.91. What is the ratio of the Unemployed and educated labor force (% of population) in Hong Kong in 2011 to that in 2012?
Make the answer very short. 1.01. What is the ratio of the Unemployed and educated labor force (% of population) in Philippines in 2011 to that in 2012?
Offer a terse response. 1. What is the ratio of the Unemployed and educated labor force (% of population) in United States in 2011 to that in 2012?
Keep it short and to the point. 1. What is the difference between the highest and the second highest Unemployed and educated labor force (% of population) of Bosnia and Herzegovina?
Give a very brief answer. 0.2. What is the difference between the highest and the second highest Unemployed and educated labor force (% of population) of Philippines?
Make the answer very short. 0.4. What is the difference between the highest and the lowest Unemployed and educated labor force (% of population) of United States?
Offer a terse response. 32.1. 